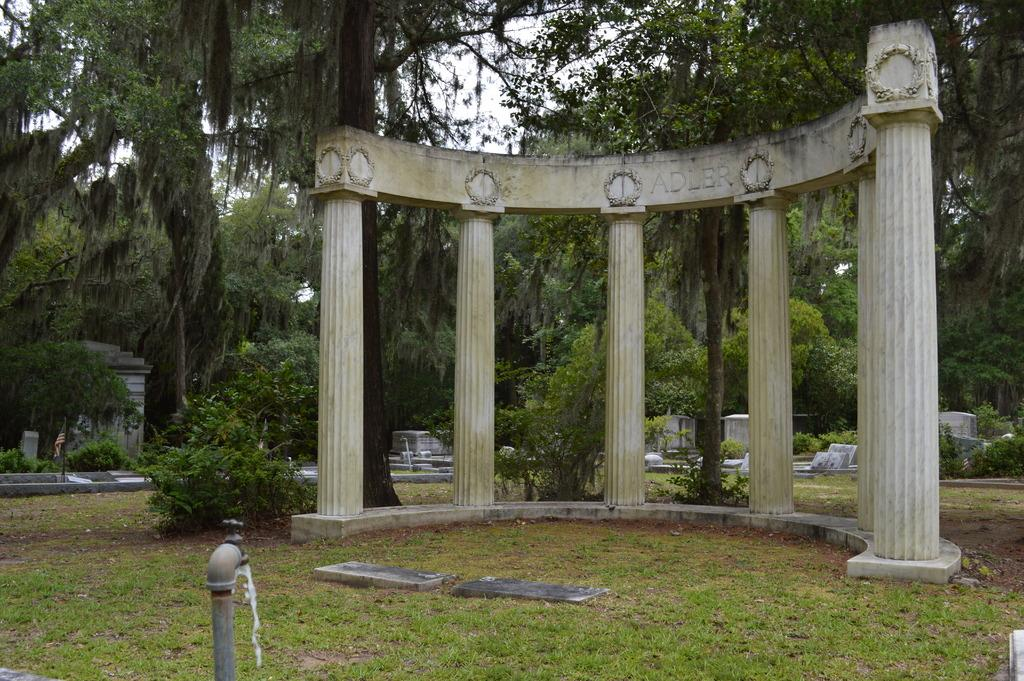What type of structure is visible in the image? There is a construction with pillars in the image. What natural elements can be seen in the image? There are trees in the image. What man-made object is present in the image? There is a pipeline in the image. What device is used for dispensing water in the image? There is a tap in the image. What symbolic object is present in the image? There is a flag in the image. What is the flag attached to in the image? There is a flag post in the image. What part of the natural environment is visible in the image? The sky is visible in the image. What type of juice is being squeezed from the fowl in the image? There is no fowl or juice present in the image. What force is being applied to the construction in the image? There is no force being applied to the construction in the image; it appears to be stationary. 